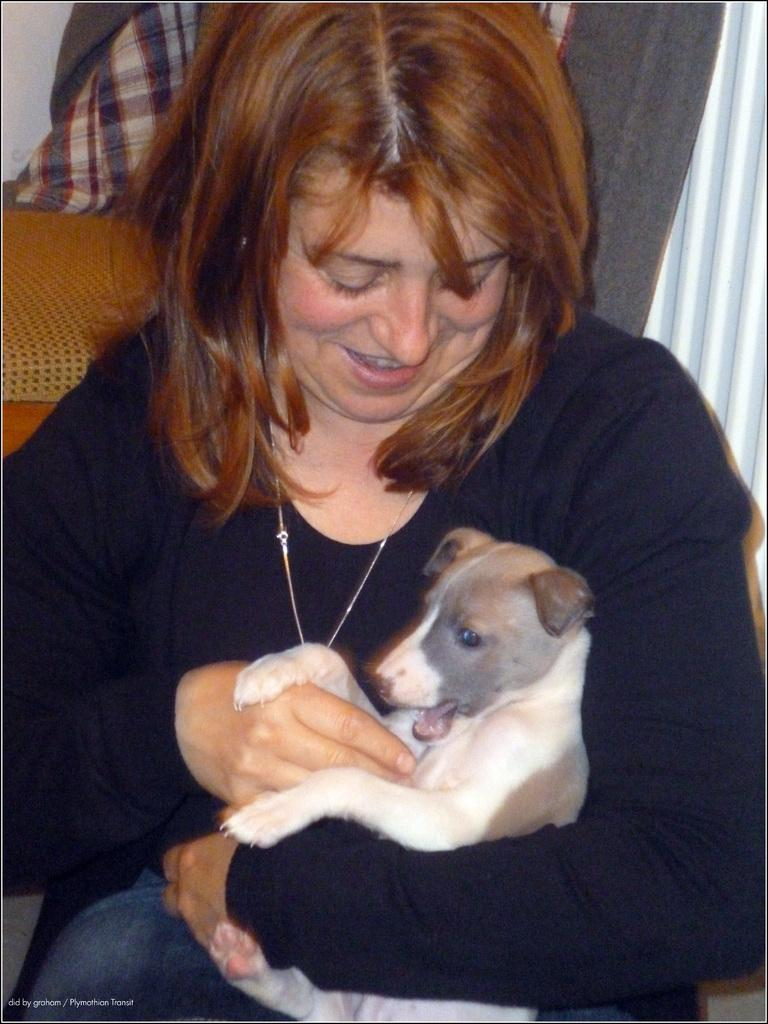Who is the main subject in the image? There is a woman in the image. What is the woman holding in her hands? The woman is holding a dog in her hands. What is the dog's position in relation to the woman? The dog is in her hands. What is the woman's facial expression in the image? The woman is smiling. What type of brick is the woman using to build a wall in the image? There is no brick or wall-building activity present in the image. 